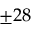<formula> <loc_0><loc_0><loc_500><loc_500>\pm 2 8</formula> 